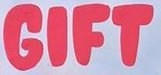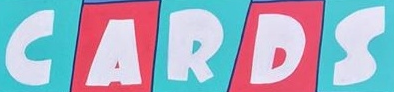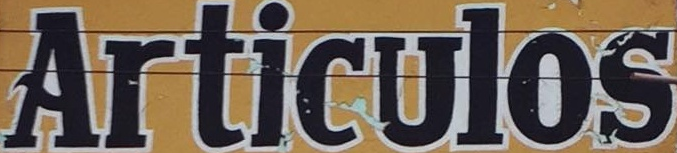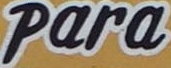Transcribe the words shown in these images in order, separated by a semicolon. GIFT; CARDS; Articulos; Para 